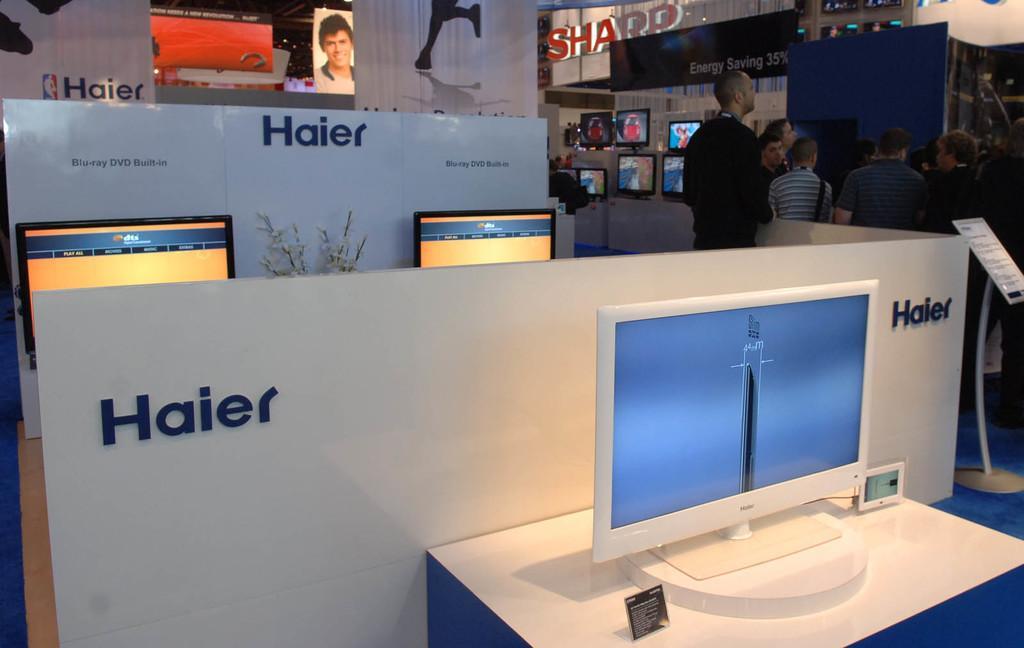Please provide a concise description of this image. In this picture we can see the screens, boards. On the boards we can see the text. In the center of the image we can see a plant. On the right side of the image we can see the screens, boards and some people are standing. 